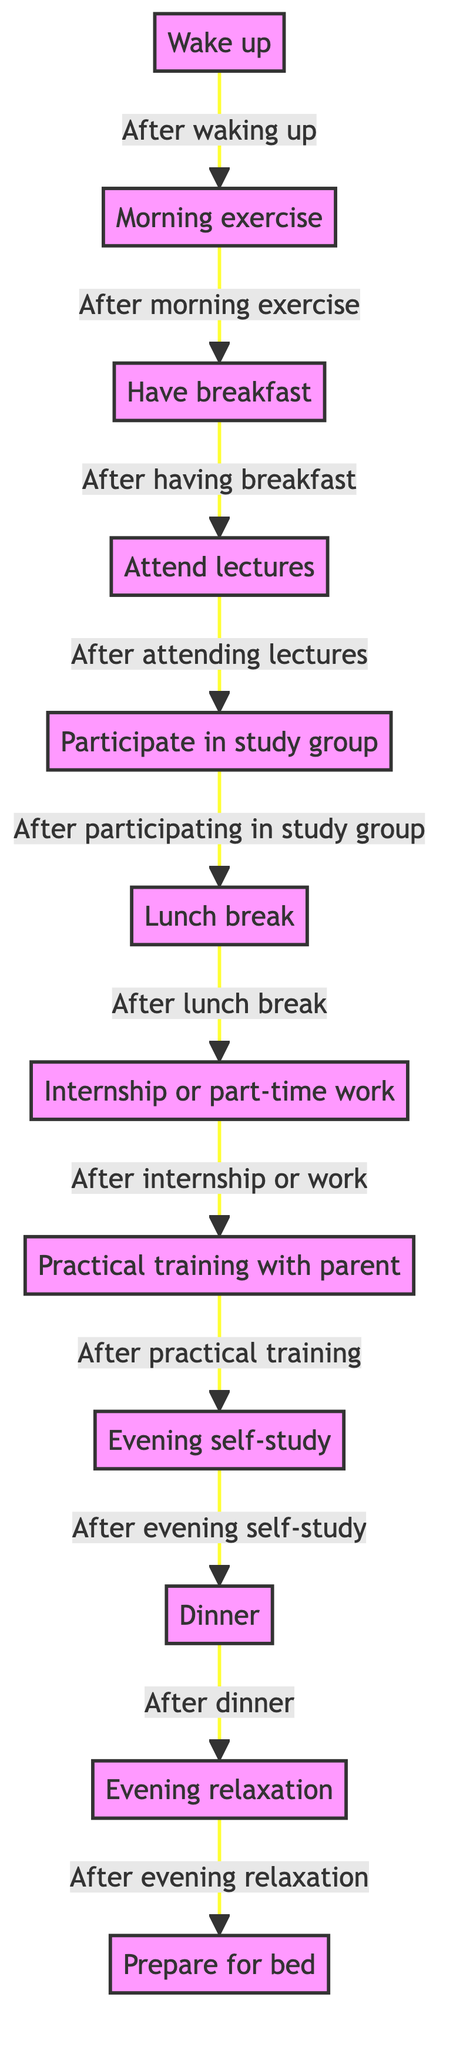What is the first activity in the diagram? The diagram starts with the first activity labeled "Wake up," which is the first node leading to the next activity.
Answer: Wake up How many activities are there in the diagram? Counting all the activities listed in the data, there are a total of 12 distinct activities represented in the diagram.
Answer: 12 What is the last activity before preparing for bed? The activity that comes just before "Prepare for bed" is "Evening relaxation," which is connected as the last activity in the sequence leading up to bedtime.
Answer: Evening relaxation What activity follows after lunch break? In the diagram, "Lunch break" is followed by "Internship or part-time work," showing the transition from taking a break to work.
Answer: Internship or part-time work Which activity occurs after participating in a study group? The activity that takes place directly after "Participate in study group" is "Lunch break," indicating that study sessions are followed by a meal break.
Answer: Lunch break What can be inferred about the sequence of activities related to study? The sequence includes "Attend lectures," followed by "Participate in study group," and then "Evening self-study," indicating a structured approach to learning with a focus on both collaboration and individual review.
Answer: Attend lectures → Participate in study group → Evening self-study Are there any activities related to physical exercise? Yes, the diagram includes "Morning exercise," which specifically indicates an activity focused on physical health as part of the daily routine.
Answer: Morning exercise Is there an activity that combines practical experience with parental guidance? Yes, "Practical training with parent" involves gaining hands-on experience supported by the student's parent, reflecting a unique part of their educational journey.
Answer: Practical training with parent What does the transition from "Dinner" lead to? The transition from "Dinner" leads to "Evening relaxation," indicating that after dinner, the student takes time to relax.
Answer: Evening relaxation 